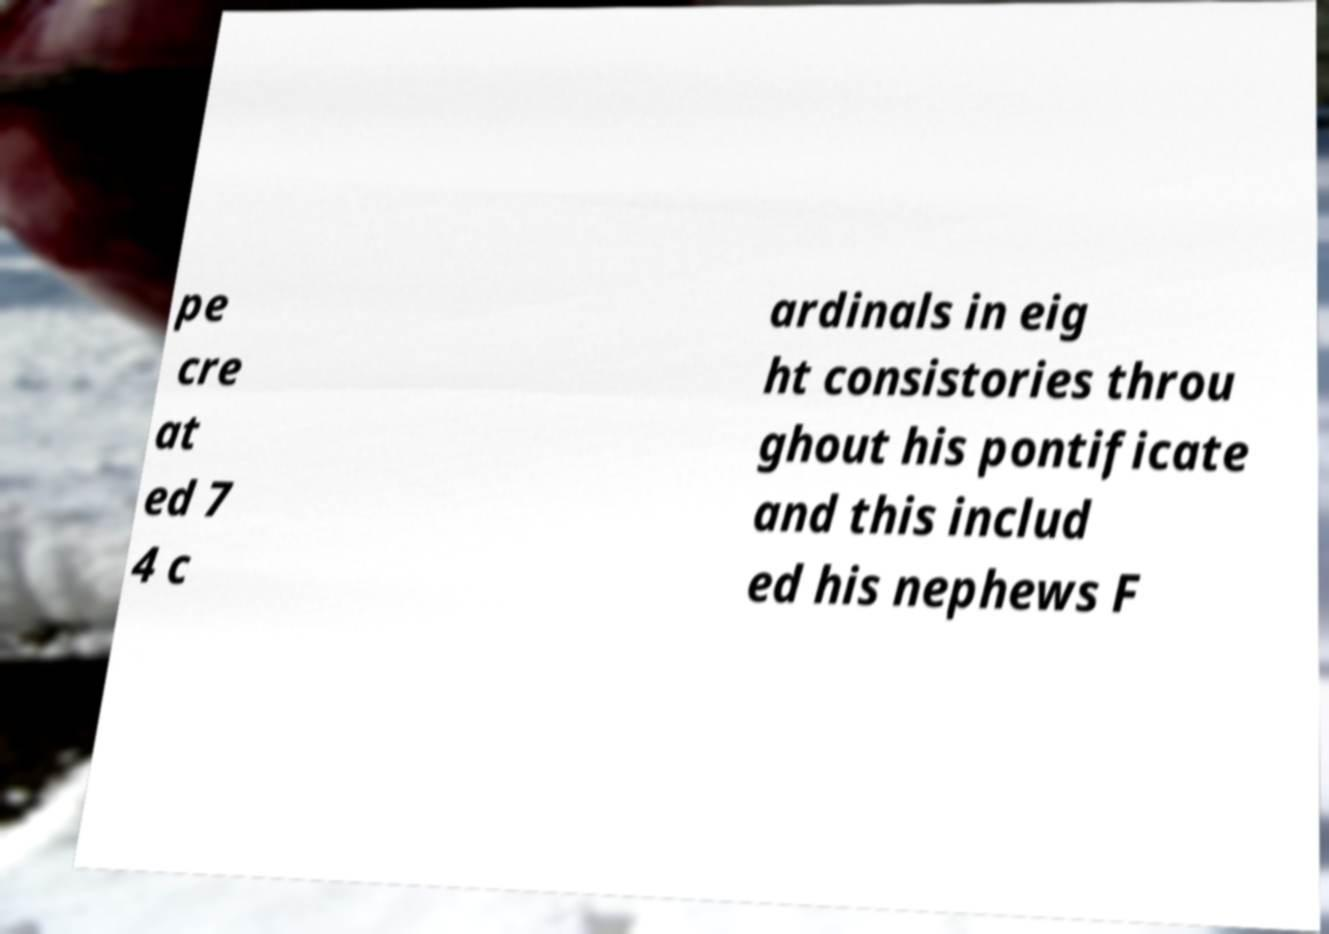Can you accurately transcribe the text from the provided image for me? pe cre at ed 7 4 c ardinals in eig ht consistories throu ghout his pontificate and this includ ed his nephews F 